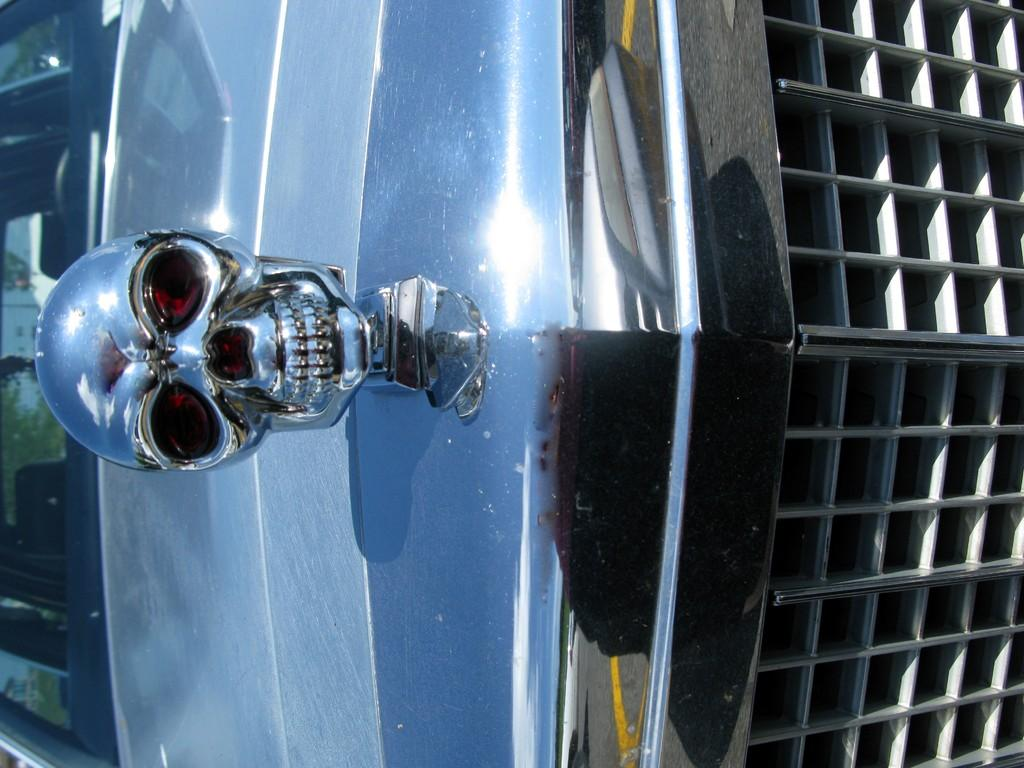What type of vehicle is in the image? There is a vehicle in the image, but the specific type cannot be determined from the provided facts. What is unique about the front of the vehicle? The vehicle has a skull structure at the front. Where is the window located on the vehicle? There is a window on the left side of the vehicle. What can be seen through the window? Trees are visible through the window. How many chairs are visible in the image? There are no chairs present in the image. What color is the nose of the vehicle in the image? The vehicle does not have a nose, as it has a skull structure at the front. 